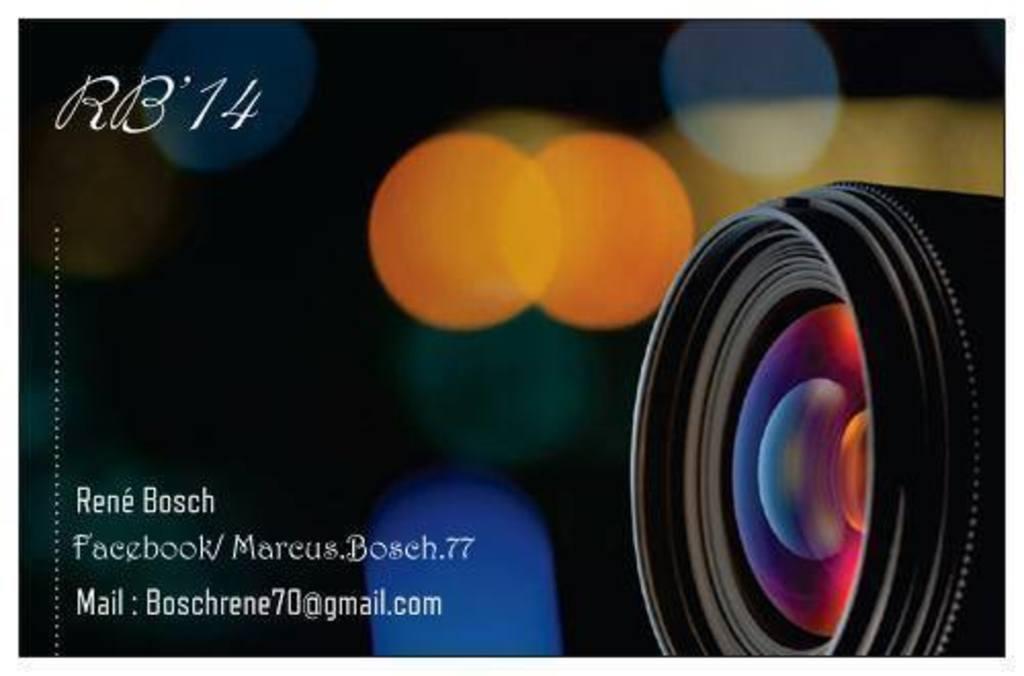Please provide a concise description of this image. On the left side of the image we can see the text. On the right side of the image we can see a camera. In the background of the image we can see the lights. 